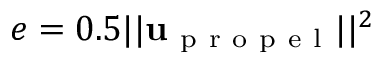Convert formula to latex. <formula><loc_0><loc_0><loc_500><loc_500>e = 0 . 5 | | u _ { p r o p e l } | | ^ { 2 }</formula> 